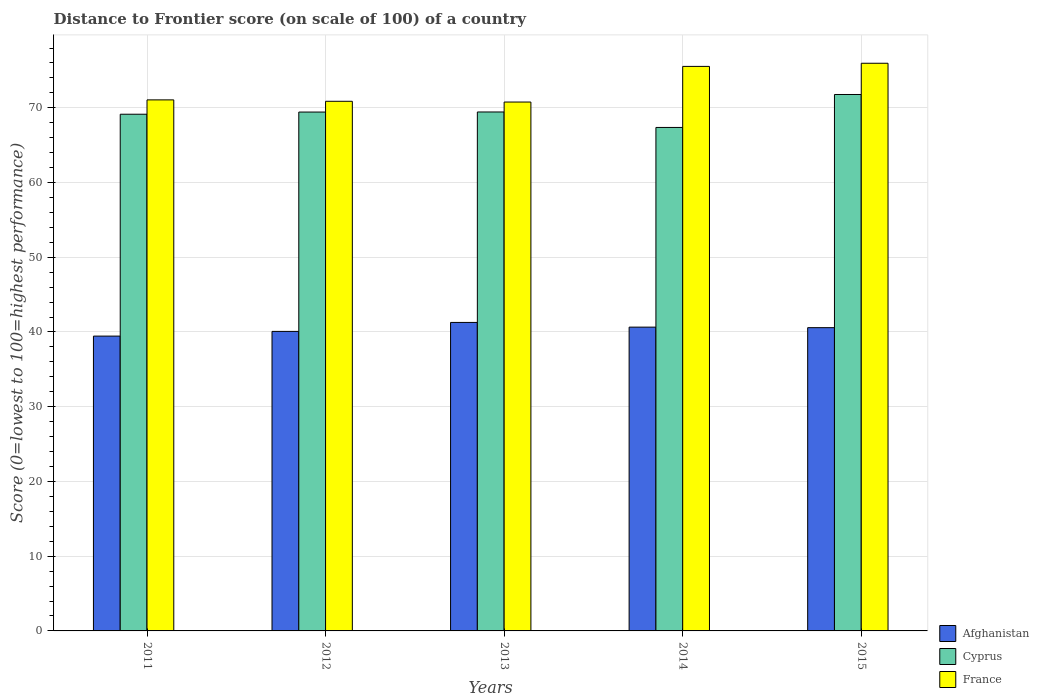How many groups of bars are there?
Offer a terse response. 5. Are the number of bars on each tick of the X-axis equal?
Your answer should be compact. Yes. How many bars are there on the 3rd tick from the left?
Make the answer very short. 3. How many bars are there on the 5th tick from the right?
Provide a succinct answer. 3. What is the label of the 2nd group of bars from the left?
Provide a succinct answer. 2012. In how many cases, is the number of bars for a given year not equal to the number of legend labels?
Provide a short and direct response. 0. What is the distance to frontier score of in Afghanistan in 2015?
Your answer should be compact. 40.58. Across all years, what is the maximum distance to frontier score of in France?
Offer a very short reply. 75.96. Across all years, what is the minimum distance to frontier score of in France?
Your answer should be compact. 70.77. In which year was the distance to frontier score of in France maximum?
Offer a terse response. 2015. In which year was the distance to frontier score of in Afghanistan minimum?
Ensure brevity in your answer.  2011. What is the total distance to frontier score of in France in the graph?
Give a very brief answer. 364.2. What is the difference between the distance to frontier score of in Afghanistan in 2012 and that in 2015?
Give a very brief answer. -0.5. What is the difference between the distance to frontier score of in Cyprus in 2011 and the distance to frontier score of in France in 2015?
Your answer should be very brief. -6.82. What is the average distance to frontier score of in Cyprus per year?
Offer a terse response. 69.43. In the year 2012, what is the difference between the distance to frontier score of in Afghanistan and distance to frontier score of in Cyprus?
Your response must be concise. -29.35. In how many years, is the distance to frontier score of in Afghanistan greater than 18?
Keep it short and to the point. 5. What is the ratio of the distance to frontier score of in France in 2011 to that in 2015?
Provide a succinct answer. 0.94. Is the distance to frontier score of in France in 2013 less than that in 2014?
Your answer should be very brief. Yes. What is the difference between the highest and the second highest distance to frontier score of in Afghanistan?
Keep it short and to the point. 0.63. What is the difference between the highest and the lowest distance to frontier score of in France?
Ensure brevity in your answer.  5.19. Is the sum of the distance to frontier score of in Afghanistan in 2011 and 2014 greater than the maximum distance to frontier score of in France across all years?
Offer a terse response. Yes. What does the 2nd bar from the left in 2011 represents?
Make the answer very short. Cyprus. What does the 1st bar from the right in 2012 represents?
Ensure brevity in your answer.  France. Are all the bars in the graph horizontal?
Provide a succinct answer. No. How many years are there in the graph?
Your response must be concise. 5. What is the difference between two consecutive major ticks on the Y-axis?
Your response must be concise. 10. Does the graph contain any zero values?
Provide a short and direct response. No. How many legend labels are there?
Your response must be concise. 3. How are the legend labels stacked?
Provide a short and direct response. Vertical. What is the title of the graph?
Your response must be concise. Distance to Frontier score (on scale of 100) of a country. Does "Kosovo" appear as one of the legend labels in the graph?
Provide a short and direct response. No. What is the label or title of the X-axis?
Offer a very short reply. Years. What is the label or title of the Y-axis?
Make the answer very short. Score (0=lowest to 100=highest performance). What is the Score (0=lowest to 100=highest performance) of Afghanistan in 2011?
Keep it short and to the point. 39.45. What is the Score (0=lowest to 100=highest performance) in Cyprus in 2011?
Your answer should be compact. 69.14. What is the Score (0=lowest to 100=highest performance) of France in 2011?
Offer a terse response. 71.06. What is the Score (0=lowest to 100=highest performance) of Afghanistan in 2012?
Your answer should be very brief. 40.08. What is the Score (0=lowest to 100=highest performance) of Cyprus in 2012?
Make the answer very short. 69.43. What is the Score (0=lowest to 100=highest performance) in France in 2012?
Give a very brief answer. 70.87. What is the Score (0=lowest to 100=highest performance) in Afghanistan in 2013?
Provide a short and direct response. 41.28. What is the Score (0=lowest to 100=highest performance) in Cyprus in 2013?
Your response must be concise. 69.44. What is the Score (0=lowest to 100=highest performance) of France in 2013?
Keep it short and to the point. 70.77. What is the Score (0=lowest to 100=highest performance) in Afghanistan in 2014?
Offer a terse response. 40.65. What is the Score (0=lowest to 100=highest performance) of Cyprus in 2014?
Provide a short and direct response. 67.37. What is the Score (0=lowest to 100=highest performance) in France in 2014?
Provide a short and direct response. 75.54. What is the Score (0=lowest to 100=highest performance) in Afghanistan in 2015?
Offer a very short reply. 40.58. What is the Score (0=lowest to 100=highest performance) in Cyprus in 2015?
Provide a succinct answer. 71.78. What is the Score (0=lowest to 100=highest performance) in France in 2015?
Offer a terse response. 75.96. Across all years, what is the maximum Score (0=lowest to 100=highest performance) of Afghanistan?
Your answer should be very brief. 41.28. Across all years, what is the maximum Score (0=lowest to 100=highest performance) of Cyprus?
Ensure brevity in your answer.  71.78. Across all years, what is the maximum Score (0=lowest to 100=highest performance) of France?
Your answer should be compact. 75.96. Across all years, what is the minimum Score (0=lowest to 100=highest performance) of Afghanistan?
Your response must be concise. 39.45. Across all years, what is the minimum Score (0=lowest to 100=highest performance) in Cyprus?
Give a very brief answer. 67.37. Across all years, what is the minimum Score (0=lowest to 100=highest performance) in France?
Keep it short and to the point. 70.77. What is the total Score (0=lowest to 100=highest performance) in Afghanistan in the graph?
Offer a terse response. 202.04. What is the total Score (0=lowest to 100=highest performance) of Cyprus in the graph?
Give a very brief answer. 347.16. What is the total Score (0=lowest to 100=highest performance) of France in the graph?
Provide a succinct answer. 364.2. What is the difference between the Score (0=lowest to 100=highest performance) of Afghanistan in 2011 and that in 2012?
Keep it short and to the point. -0.63. What is the difference between the Score (0=lowest to 100=highest performance) in Cyprus in 2011 and that in 2012?
Ensure brevity in your answer.  -0.29. What is the difference between the Score (0=lowest to 100=highest performance) in France in 2011 and that in 2012?
Give a very brief answer. 0.19. What is the difference between the Score (0=lowest to 100=highest performance) in Afghanistan in 2011 and that in 2013?
Ensure brevity in your answer.  -1.83. What is the difference between the Score (0=lowest to 100=highest performance) in France in 2011 and that in 2013?
Offer a terse response. 0.29. What is the difference between the Score (0=lowest to 100=highest performance) in Cyprus in 2011 and that in 2014?
Make the answer very short. 1.77. What is the difference between the Score (0=lowest to 100=highest performance) of France in 2011 and that in 2014?
Keep it short and to the point. -4.48. What is the difference between the Score (0=lowest to 100=highest performance) in Afghanistan in 2011 and that in 2015?
Keep it short and to the point. -1.13. What is the difference between the Score (0=lowest to 100=highest performance) of Cyprus in 2011 and that in 2015?
Give a very brief answer. -2.64. What is the difference between the Score (0=lowest to 100=highest performance) of France in 2011 and that in 2015?
Offer a terse response. -4.9. What is the difference between the Score (0=lowest to 100=highest performance) of Afghanistan in 2012 and that in 2013?
Give a very brief answer. -1.2. What is the difference between the Score (0=lowest to 100=highest performance) of Cyprus in 2012 and that in 2013?
Your answer should be compact. -0.01. What is the difference between the Score (0=lowest to 100=highest performance) in Afghanistan in 2012 and that in 2014?
Provide a short and direct response. -0.57. What is the difference between the Score (0=lowest to 100=highest performance) in Cyprus in 2012 and that in 2014?
Your answer should be compact. 2.06. What is the difference between the Score (0=lowest to 100=highest performance) in France in 2012 and that in 2014?
Give a very brief answer. -4.67. What is the difference between the Score (0=lowest to 100=highest performance) of Cyprus in 2012 and that in 2015?
Provide a succinct answer. -2.35. What is the difference between the Score (0=lowest to 100=highest performance) of France in 2012 and that in 2015?
Provide a short and direct response. -5.09. What is the difference between the Score (0=lowest to 100=highest performance) in Afghanistan in 2013 and that in 2014?
Give a very brief answer. 0.63. What is the difference between the Score (0=lowest to 100=highest performance) of Cyprus in 2013 and that in 2014?
Keep it short and to the point. 2.07. What is the difference between the Score (0=lowest to 100=highest performance) in France in 2013 and that in 2014?
Provide a short and direct response. -4.77. What is the difference between the Score (0=lowest to 100=highest performance) of Afghanistan in 2013 and that in 2015?
Ensure brevity in your answer.  0.7. What is the difference between the Score (0=lowest to 100=highest performance) of Cyprus in 2013 and that in 2015?
Give a very brief answer. -2.34. What is the difference between the Score (0=lowest to 100=highest performance) of France in 2013 and that in 2015?
Your answer should be very brief. -5.19. What is the difference between the Score (0=lowest to 100=highest performance) of Afghanistan in 2014 and that in 2015?
Keep it short and to the point. 0.07. What is the difference between the Score (0=lowest to 100=highest performance) in Cyprus in 2014 and that in 2015?
Provide a short and direct response. -4.41. What is the difference between the Score (0=lowest to 100=highest performance) of France in 2014 and that in 2015?
Give a very brief answer. -0.42. What is the difference between the Score (0=lowest to 100=highest performance) of Afghanistan in 2011 and the Score (0=lowest to 100=highest performance) of Cyprus in 2012?
Your response must be concise. -29.98. What is the difference between the Score (0=lowest to 100=highest performance) of Afghanistan in 2011 and the Score (0=lowest to 100=highest performance) of France in 2012?
Keep it short and to the point. -31.42. What is the difference between the Score (0=lowest to 100=highest performance) in Cyprus in 2011 and the Score (0=lowest to 100=highest performance) in France in 2012?
Provide a short and direct response. -1.73. What is the difference between the Score (0=lowest to 100=highest performance) in Afghanistan in 2011 and the Score (0=lowest to 100=highest performance) in Cyprus in 2013?
Your answer should be very brief. -29.99. What is the difference between the Score (0=lowest to 100=highest performance) of Afghanistan in 2011 and the Score (0=lowest to 100=highest performance) of France in 2013?
Provide a short and direct response. -31.32. What is the difference between the Score (0=lowest to 100=highest performance) of Cyprus in 2011 and the Score (0=lowest to 100=highest performance) of France in 2013?
Your answer should be very brief. -1.63. What is the difference between the Score (0=lowest to 100=highest performance) of Afghanistan in 2011 and the Score (0=lowest to 100=highest performance) of Cyprus in 2014?
Provide a succinct answer. -27.92. What is the difference between the Score (0=lowest to 100=highest performance) in Afghanistan in 2011 and the Score (0=lowest to 100=highest performance) in France in 2014?
Provide a short and direct response. -36.09. What is the difference between the Score (0=lowest to 100=highest performance) of Cyprus in 2011 and the Score (0=lowest to 100=highest performance) of France in 2014?
Offer a very short reply. -6.4. What is the difference between the Score (0=lowest to 100=highest performance) in Afghanistan in 2011 and the Score (0=lowest to 100=highest performance) in Cyprus in 2015?
Offer a terse response. -32.33. What is the difference between the Score (0=lowest to 100=highest performance) in Afghanistan in 2011 and the Score (0=lowest to 100=highest performance) in France in 2015?
Ensure brevity in your answer.  -36.51. What is the difference between the Score (0=lowest to 100=highest performance) in Cyprus in 2011 and the Score (0=lowest to 100=highest performance) in France in 2015?
Make the answer very short. -6.82. What is the difference between the Score (0=lowest to 100=highest performance) in Afghanistan in 2012 and the Score (0=lowest to 100=highest performance) in Cyprus in 2013?
Offer a very short reply. -29.36. What is the difference between the Score (0=lowest to 100=highest performance) in Afghanistan in 2012 and the Score (0=lowest to 100=highest performance) in France in 2013?
Provide a succinct answer. -30.69. What is the difference between the Score (0=lowest to 100=highest performance) of Cyprus in 2012 and the Score (0=lowest to 100=highest performance) of France in 2013?
Offer a terse response. -1.34. What is the difference between the Score (0=lowest to 100=highest performance) of Afghanistan in 2012 and the Score (0=lowest to 100=highest performance) of Cyprus in 2014?
Your response must be concise. -27.29. What is the difference between the Score (0=lowest to 100=highest performance) in Afghanistan in 2012 and the Score (0=lowest to 100=highest performance) in France in 2014?
Give a very brief answer. -35.46. What is the difference between the Score (0=lowest to 100=highest performance) in Cyprus in 2012 and the Score (0=lowest to 100=highest performance) in France in 2014?
Keep it short and to the point. -6.11. What is the difference between the Score (0=lowest to 100=highest performance) of Afghanistan in 2012 and the Score (0=lowest to 100=highest performance) of Cyprus in 2015?
Offer a very short reply. -31.7. What is the difference between the Score (0=lowest to 100=highest performance) of Afghanistan in 2012 and the Score (0=lowest to 100=highest performance) of France in 2015?
Ensure brevity in your answer.  -35.88. What is the difference between the Score (0=lowest to 100=highest performance) of Cyprus in 2012 and the Score (0=lowest to 100=highest performance) of France in 2015?
Keep it short and to the point. -6.53. What is the difference between the Score (0=lowest to 100=highest performance) in Afghanistan in 2013 and the Score (0=lowest to 100=highest performance) in Cyprus in 2014?
Ensure brevity in your answer.  -26.09. What is the difference between the Score (0=lowest to 100=highest performance) in Afghanistan in 2013 and the Score (0=lowest to 100=highest performance) in France in 2014?
Keep it short and to the point. -34.26. What is the difference between the Score (0=lowest to 100=highest performance) of Afghanistan in 2013 and the Score (0=lowest to 100=highest performance) of Cyprus in 2015?
Provide a succinct answer. -30.5. What is the difference between the Score (0=lowest to 100=highest performance) of Afghanistan in 2013 and the Score (0=lowest to 100=highest performance) of France in 2015?
Your response must be concise. -34.68. What is the difference between the Score (0=lowest to 100=highest performance) of Cyprus in 2013 and the Score (0=lowest to 100=highest performance) of France in 2015?
Keep it short and to the point. -6.52. What is the difference between the Score (0=lowest to 100=highest performance) in Afghanistan in 2014 and the Score (0=lowest to 100=highest performance) in Cyprus in 2015?
Your answer should be very brief. -31.13. What is the difference between the Score (0=lowest to 100=highest performance) in Afghanistan in 2014 and the Score (0=lowest to 100=highest performance) in France in 2015?
Keep it short and to the point. -35.31. What is the difference between the Score (0=lowest to 100=highest performance) of Cyprus in 2014 and the Score (0=lowest to 100=highest performance) of France in 2015?
Your answer should be compact. -8.59. What is the average Score (0=lowest to 100=highest performance) in Afghanistan per year?
Make the answer very short. 40.41. What is the average Score (0=lowest to 100=highest performance) in Cyprus per year?
Keep it short and to the point. 69.43. What is the average Score (0=lowest to 100=highest performance) in France per year?
Ensure brevity in your answer.  72.84. In the year 2011, what is the difference between the Score (0=lowest to 100=highest performance) of Afghanistan and Score (0=lowest to 100=highest performance) of Cyprus?
Offer a very short reply. -29.69. In the year 2011, what is the difference between the Score (0=lowest to 100=highest performance) in Afghanistan and Score (0=lowest to 100=highest performance) in France?
Your answer should be very brief. -31.61. In the year 2011, what is the difference between the Score (0=lowest to 100=highest performance) of Cyprus and Score (0=lowest to 100=highest performance) of France?
Offer a terse response. -1.92. In the year 2012, what is the difference between the Score (0=lowest to 100=highest performance) of Afghanistan and Score (0=lowest to 100=highest performance) of Cyprus?
Offer a terse response. -29.35. In the year 2012, what is the difference between the Score (0=lowest to 100=highest performance) in Afghanistan and Score (0=lowest to 100=highest performance) in France?
Your answer should be very brief. -30.79. In the year 2012, what is the difference between the Score (0=lowest to 100=highest performance) of Cyprus and Score (0=lowest to 100=highest performance) of France?
Offer a terse response. -1.44. In the year 2013, what is the difference between the Score (0=lowest to 100=highest performance) of Afghanistan and Score (0=lowest to 100=highest performance) of Cyprus?
Offer a very short reply. -28.16. In the year 2013, what is the difference between the Score (0=lowest to 100=highest performance) of Afghanistan and Score (0=lowest to 100=highest performance) of France?
Make the answer very short. -29.49. In the year 2013, what is the difference between the Score (0=lowest to 100=highest performance) in Cyprus and Score (0=lowest to 100=highest performance) in France?
Keep it short and to the point. -1.33. In the year 2014, what is the difference between the Score (0=lowest to 100=highest performance) of Afghanistan and Score (0=lowest to 100=highest performance) of Cyprus?
Provide a short and direct response. -26.72. In the year 2014, what is the difference between the Score (0=lowest to 100=highest performance) of Afghanistan and Score (0=lowest to 100=highest performance) of France?
Ensure brevity in your answer.  -34.89. In the year 2014, what is the difference between the Score (0=lowest to 100=highest performance) of Cyprus and Score (0=lowest to 100=highest performance) of France?
Your answer should be very brief. -8.17. In the year 2015, what is the difference between the Score (0=lowest to 100=highest performance) of Afghanistan and Score (0=lowest to 100=highest performance) of Cyprus?
Offer a terse response. -31.2. In the year 2015, what is the difference between the Score (0=lowest to 100=highest performance) of Afghanistan and Score (0=lowest to 100=highest performance) of France?
Provide a short and direct response. -35.38. In the year 2015, what is the difference between the Score (0=lowest to 100=highest performance) in Cyprus and Score (0=lowest to 100=highest performance) in France?
Offer a terse response. -4.18. What is the ratio of the Score (0=lowest to 100=highest performance) in Afghanistan in 2011 to that in 2012?
Give a very brief answer. 0.98. What is the ratio of the Score (0=lowest to 100=highest performance) in Afghanistan in 2011 to that in 2013?
Keep it short and to the point. 0.96. What is the ratio of the Score (0=lowest to 100=highest performance) of Cyprus in 2011 to that in 2013?
Ensure brevity in your answer.  1. What is the ratio of the Score (0=lowest to 100=highest performance) of Afghanistan in 2011 to that in 2014?
Your answer should be compact. 0.97. What is the ratio of the Score (0=lowest to 100=highest performance) in Cyprus in 2011 to that in 2014?
Ensure brevity in your answer.  1.03. What is the ratio of the Score (0=lowest to 100=highest performance) in France in 2011 to that in 2014?
Provide a succinct answer. 0.94. What is the ratio of the Score (0=lowest to 100=highest performance) in Afghanistan in 2011 to that in 2015?
Your answer should be very brief. 0.97. What is the ratio of the Score (0=lowest to 100=highest performance) in Cyprus in 2011 to that in 2015?
Make the answer very short. 0.96. What is the ratio of the Score (0=lowest to 100=highest performance) of France in 2011 to that in 2015?
Make the answer very short. 0.94. What is the ratio of the Score (0=lowest to 100=highest performance) of Afghanistan in 2012 to that in 2013?
Offer a terse response. 0.97. What is the ratio of the Score (0=lowest to 100=highest performance) in Cyprus in 2012 to that in 2013?
Provide a short and direct response. 1. What is the ratio of the Score (0=lowest to 100=highest performance) of France in 2012 to that in 2013?
Ensure brevity in your answer.  1. What is the ratio of the Score (0=lowest to 100=highest performance) of Afghanistan in 2012 to that in 2014?
Your answer should be compact. 0.99. What is the ratio of the Score (0=lowest to 100=highest performance) in Cyprus in 2012 to that in 2014?
Offer a terse response. 1.03. What is the ratio of the Score (0=lowest to 100=highest performance) of France in 2012 to that in 2014?
Provide a succinct answer. 0.94. What is the ratio of the Score (0=lowest to 100=highest performance) of Cyprus in 2012 to that in 2015?
Offer a very short reply. 0.97. What is the ratio of the Score (0=lowest to 100=highest performance) of France in 2012 to that in 2015?
Keep it short and to the point. 0.93. What is the ratio of the Score (0=lowest to 100=highest performance) in Afghanistan in 2013 to that in 2014?
Your answer should be very brief. 1.02. What is the ratio of the Score (0=lowest to 100=highest performance) of Cyprus in 2013 to that in 2014?
Ensure brevity in your answer.  1.03. What is the ratio of the Score (0=lowest to 100=highest performance) of France in 2013 to that in 2014?
Your answer should be compact. 0.94. What is the ratio of the Score (0=lowest to 100=highest performance) of Afghanistan in 2013 to that in 2015?
Keep it short and to the point. 1.02. What is the ratio of the Score (0=lowest to 100=highest performance) of Cyprus in 2013 to that in 2015?
Your response must be concise. 0.97. What is the ratio of the Score (0=lowest to 100=highest performance) of France in 2013 to that in 2015?
Ensure brevity in your answer.  0.93. What is the ratio of the Score (0=lowest to 100=highest performance) in Cyprus in 2014 to that in 2015?
Provide a succinct answer. 0.94. What is the difference between the highest and the second highest Score (0=lowest to 100=highest performance) of Afghanistan?
Your answer should be compact. 0.63. What is the difference between the highest and the second highest Score (0=lowest to 100=highest performance) in Cyprus?
Provide a short and direct response. 2.34. What is the difference between the highest and the second highest Score (0=lowest to 100=highest performance) of France?
Provide a short and direct response. 0.42. What is the difference between the highest and the lowest Score (0=lowest to 100=highest performance) in Afghanistan?
Provide a short and direct response. 1.83. What is the difference between the highest and the lowest Score (0=lowest to 100=highest performance) in Cyprus?
Provide a succinct answer. 4.41. What is the difference between the highest and the lowest Score (0=lowest to 100=highest performance) of France?
Offer a very short reply. 5.19. 